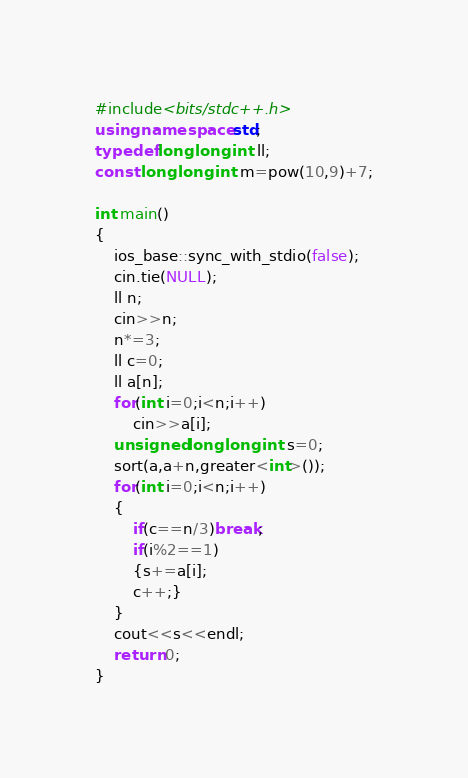<code> <loc_0><loc_0><loc_500><loc_500><_C++_>#include<bits/stdc++.h>
using namespace std; 
typedef long long int ll;
const long long int m=pow(10,9)+7;

int main()
{
    ios_base::sync_with_stdio(false);
    cin.tie(NULL);
    ll n;
    cin>>n;
    n*=3;
    ll c=0;
    ll a[n];
    for(int i=0;i<n;i++)
        cin>>a[i];
    unsigned long long int s=0;
    sort(a,a+n,greater<int>());
    for(int i=0;i<n;i++)
    {
        if(c==n/3)break;
        if(i%2==1)
        {s+=a[i];
        c++;}
    }
    cout<<s<<endl;
    return 0;
}</code> 